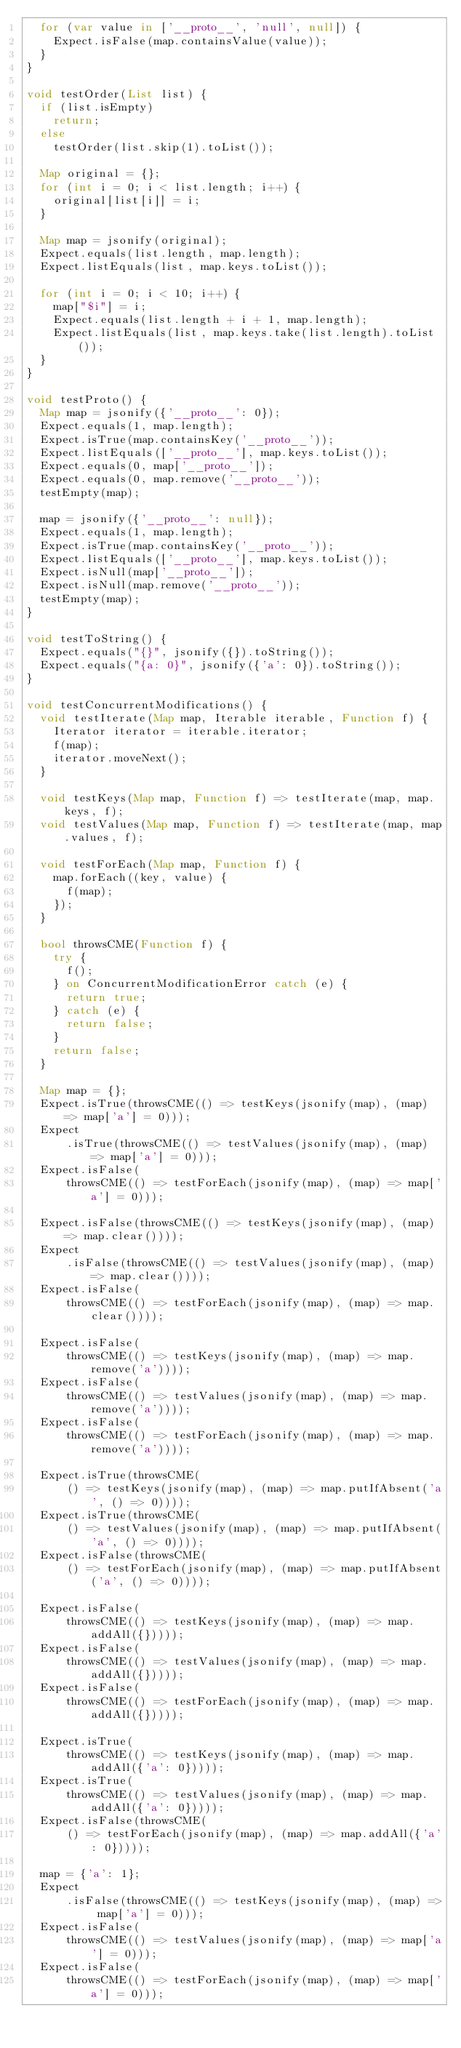<code> <loc_0><loc_0><loc_500><loc_500><_Dart_>  for (var value in ['__proto__', 'null', null]) {
    Expect.isFalse(map.containsValue(value));
  }
}

void testOrder(List list) {
  if (list.isEmpty)
    return;
  else
    testOrder(list.skip(1).toList());

  Map original = {};
  for (int i = 0; i < list.length; i++) {
    original[list[i]] = i;
  }

  Map map = jsonify(original);
  Expect.equals(list.length, map.length);
  Expect.listEquals(list, map.keys.toList());

  for (int i = 0; i < 10; i++) {
    map["$i"] = i;
    Expect.equals(list.length + i + 1, map.length);
    Expect.listEquals(list, map.keys.take(list.length).toList());
  }
}

void testProto() {
  Map map = jsonify({'__proto__': 0});
  Expect.equals(1, map.length);
  Expect.isTrue(map.containsKey('__proto__'));
  Expect.listEquals(['__proto__'], map.keys.toList());
  Expect.equals(0, map['__proto__']);
  Expect.equals(0, map.remove('__proto__'));
  testEmpty(map);

  map = jsonify({'__proto__': null});
  Expect.equals(1, map.length);
  Expect.isTrue(map.containsKey('__proto__'));
  Expect.listEquals(['__proto__'], map.keys.toList());
  Expect.isNull(map['__proto__']);
  Expect.isNull(map.remove('__proto__'));
  testEmpty(map);
}

void testToString() {
  Expect.equals("{}", jsonify({}).toString());
  Expect.equals("{a: 0}", jsonify({'a': 0}).toString());
}

void testConcurrentModifications() {
  void testIterate(Map map, Iterable iterable, Function f) {
    Iterator iterator = iterable.iterator;
    f(map);
    iterator.moveNext();
  }

  void testKeys(Map map, Function f) => testIterate(map, map.keys, f);
  void testValues(Map map, Function f) => testIterate(map, map.values, f);

  void testForEach(Map map, Function f) {
    map.forEach((key, value) {
      f(map);
    });
  }

  bool throwsCME(Function f) {
    try {
      f();
    } on ConcurrentModificationError catch (e) {
      return true;
    } catch (e) {
      return false;
    }
    return false;
  }

  Map map = {};
  Expect.isTrue(throwsCME(() => testKeys(jsonify(map), (map) => map['a'] = 0)));
  Expect
      .isTrue(throwsCME(() => testValues(jsonify(map), (map) => map['a'] = 0)));
  Expect.isFalse(
      throwsCME(() => testForEach(jsonify(map), (map) => map['a'] = 0)));

  Expect.isFalse(throwsCME(() => testKeys(jsonify(map), (map) => map.clear())));
  Expect
      .isFalse(throwsCME(() => testValues(jsonify(map), (map) => map.clear())));
  Expect.isFalse(
      throwsCME(() => testForEach(jsonify(map), (map) => map.clear())));

  Expect.isFalse(
      throwsCME(() => testKeys(jsonify(map), (map) => map.remove('a'))));
  Expect.isFalse(
      throwsCME(() => testValues(jsonify(map), (map) => map.remove('a'))));
  Expect.isFalse(
      throwsCME(() => testForEach(jsonify(map), (map) => map.remove('a'))));

  Expect.isTrue(throwsCME(
      () => testKeys(jsonify(map), (map) => map.putIfAbsent('a', () => 0))));
  Expect.isTrue(throwsCME(
      () => testValues(jsonify(map), (map) => map.putIfAbsent('a', () => 0))));
  Expect.isFalse(throwsCME(
      () => testForEach(jsonify(map), (map) => map.putIfAbsent('a', () => 0))));

  Expect.isFalse(
      throwsCME(() => testKeys(jsonify(map), (map) => map.addAll({}))));
  Expect.isFalse(
      throwsCME(() => testValues(jsonify(map), (map) => map.addAll({}))));
  Expect.isFalse(
      throwsCME(() => testForEach(jsonify(map), (map) => map.addAll({}))));

  Expect.isTrue(
      throwsCME(() => testKeys(jsonify(map), (map) => map.addAll({'a': 0}))));
  Expect.isTrue(
      throwsCME(() => testValues(jsonify(map), (map) => map.addAll({'a': 0}))));
  Expect.isFalse(throwsCME(
      () => testForEach(jsonify(map), (map) => map.addAll({'a': 0}))));

  map = {'a': 1};
  Expect
      .isFalse(throwsCME(() => testKeys(jsonify(map), (map) => map['a'] = 0)));
  Expect.isFalse(
      throwsCME(() => testValues(jsonify(map), (map) => map['a'] = 0)));
  Expect.isFalse(
      throwsCME(() => testForEach(jsonify(map), (map) => map['a'] = 0)));
</code> 